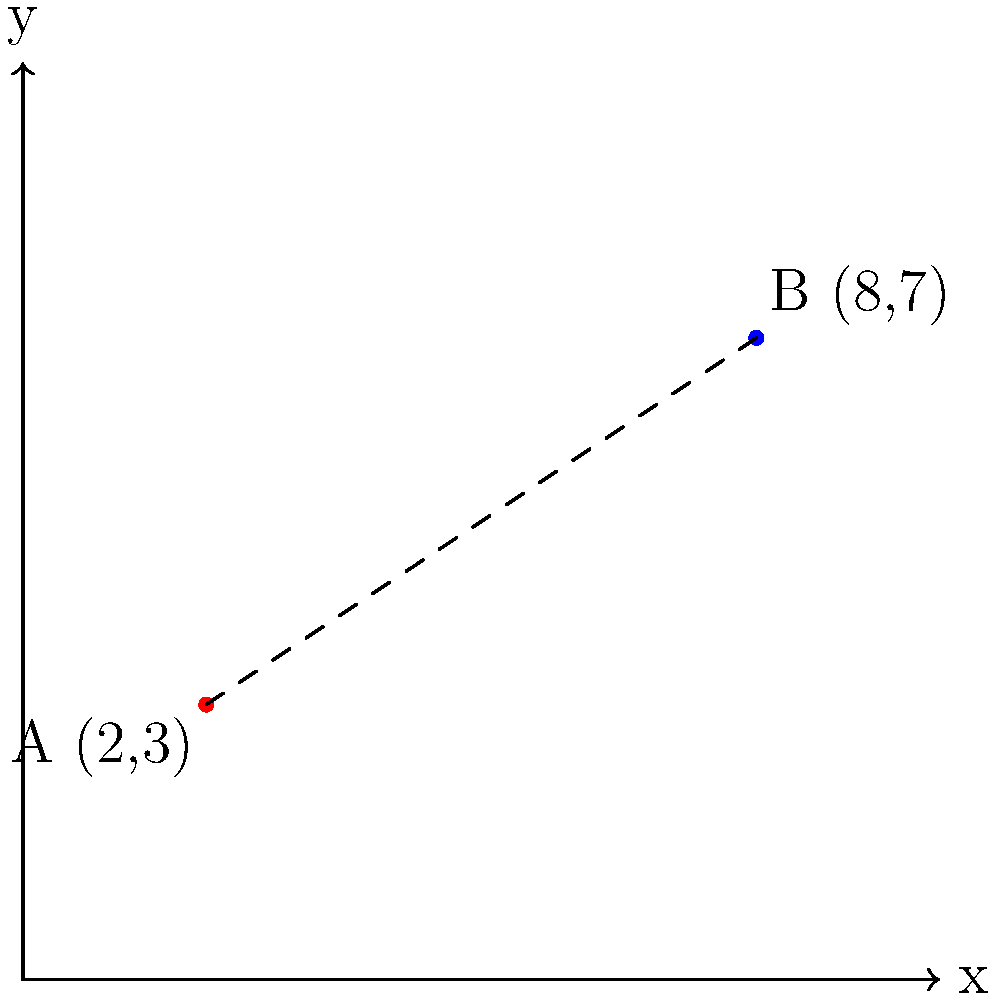As a novelist providing inspiration for original screenplays, you're working on a story about two iconic filming locations. The first location, point A, is at coordinates (2,3), and the second location, point B, is at (8,7) on a map grid where each unit represents 1 km. What is the straight-line distance between these two filming locations? To find the distance between two points on a coordinate plane, we can use the distance formula, which is derived from the Pythagorean theorem:

$$d = \sqrt{(x_2 - x_1)^2 + (y_2 - y_1)^2}$$

Where $(x_1, y_1)$ are the coordinates of the first point and $(x_2, y_2)$ are the coordinates of the second point.

Given:
Point A: $(x_1, y_1) = (2, 3)$
Point B: $(x_2, y_2) = (8, 7)$

Let's substitute these values into the formula:

$$d = \sqrt{(8 - 2)^2 + (7 - 3)^2}$$

Simplify inside the parentheses:
$$d = \sqrt{6^2 + 4^2}$$

Calculate the squares:
$$d = \sqrt{36 + 16}$$

Add under the square root:
$$d = \sqrt{52}$$

Simplify the square root:
$$d = 2\sqrt{13}$$

Since each unit represents 1 km, the distance between the two filming locations is $2\sqrt{13}$ km.
Answer: $2\sqrt{13}$ km 